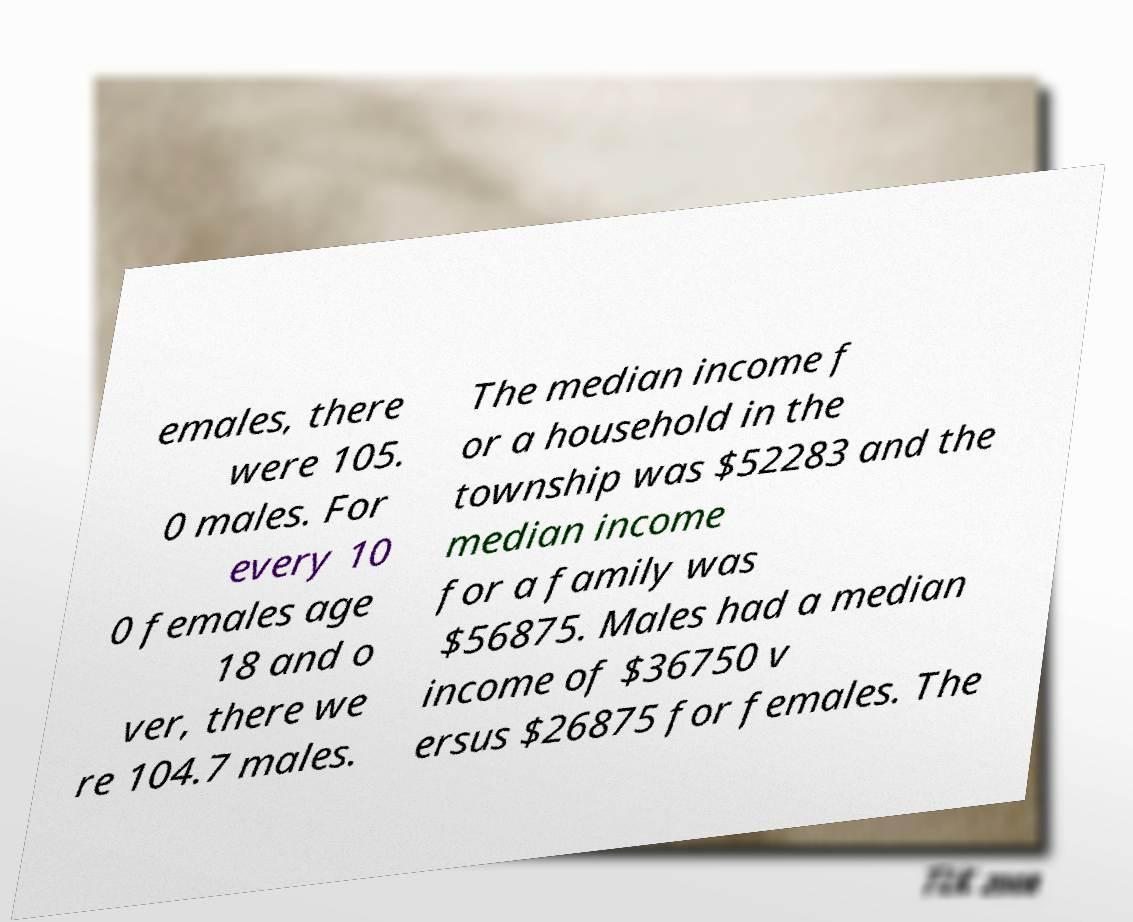Please read and relay the text visible in this image. What does it say? emales, there were 105. 0 males. For every 10 0 females age 18 and o ver, there we re 104.7 males. The median income f or a household in the township was $52283 and the median income for a family was $56875. Males had a median income of $36750 v ersus $26875 for females. The 